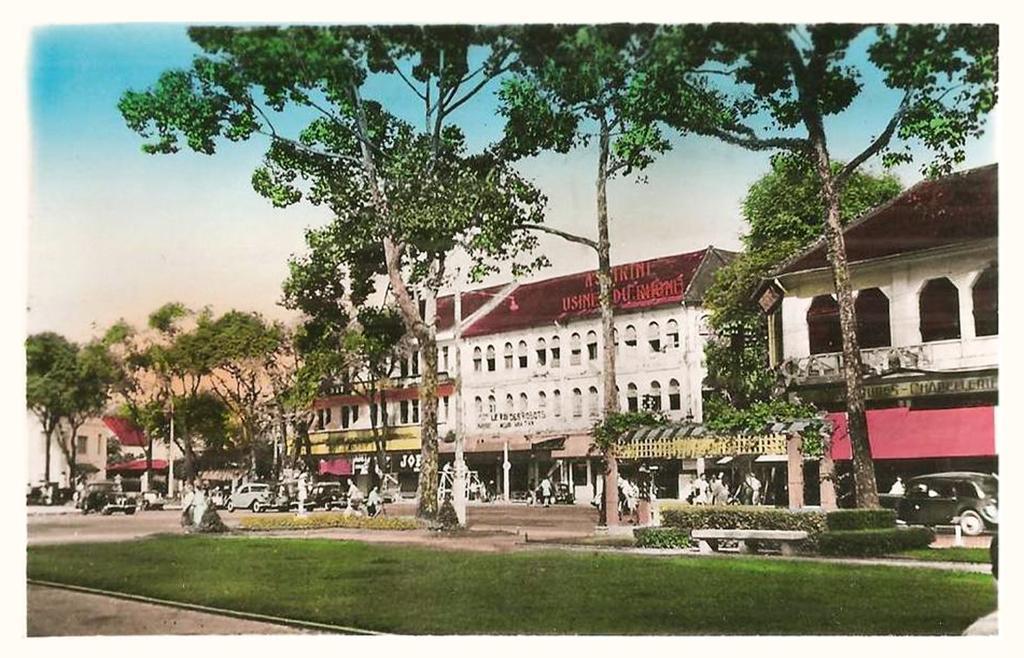Can you describe this image briefly? In this picture we can see people and vehicles on the road. We can also see many buildings, trees and grass. 